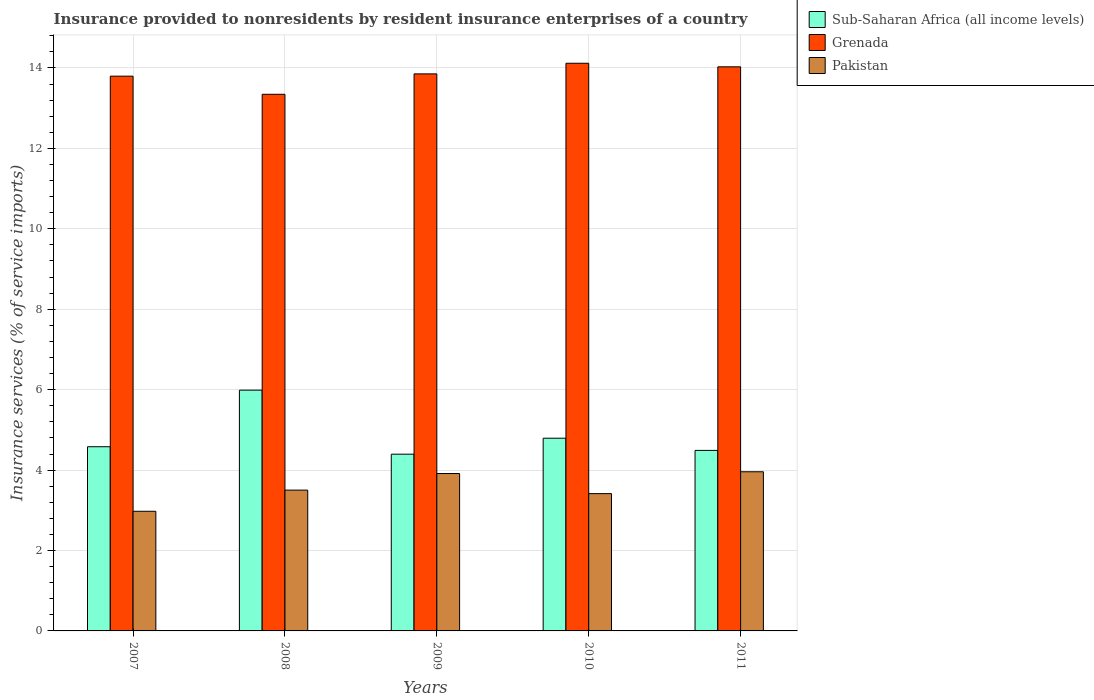Are the number of bars per tick equal to the number of legend labels?
Make the answer very short. Yes. How many bars are there on the 1st tick from the left?
Make the answer very short. 3. What is the insurance provided to nonresidents in Pakistan in 2011?
Provide a succinct answer. 3.96. Across all years, what is the maximum insurance provided to nonresidents in Sub-Saharan Africa (all income levels)?
Keep it short and to the point. 5.99. Across all years, what is the minimum insurance provided to nonresidents in Sub-Saharan Africa (all income levels)?
Keep it short and to the point. 4.4. In which year was the insurance provided to nonresidents in Pakistan maximum?
Keep it short and to the point. 2011. In which year was the insurance provided to nonresidents in Sub-Saharan Africa (all income levels) minimum?
Make the answer very short. 2009. What is the total insurance provided to nonresidents in Grenada in the graph?
Provide a succinct answer. 69.14. What is the difference between the insurance provided to nonresidents in Pakistan in 2007 and that in 2011?
Make the answer very short. -0.98. What is the difference between the insurance provided to nonresidents in Grenada in 2011 and the insurance provided to nonresidents in Sub-Saharan Africa (all income levels) in 2008?
Ensure brevity in your answer.  8.04. What is the average insurance provided to nonresidents in Pakistan per year?
Provide a succinct answer. 3.55. In the year 2008, what is the difference between the insurance provided to nonresidents in Pakistan and insurance provided to nonresidents in Grenada?
Make the answer very short. -9.84. What is the ratio of the insurance provided to nonresidents in Grenada in 2007 to that in 2008?
Ensure brevity in your answer.  1.03. What is the difference between the highest and the second highest insurance provided to nonresidents in Sub-Saharan Africa (all income levels)?
Keep it short and to the point. 1.2. What is the difference between the highest and the lowest insurance provided to nonresidents in Pakistan?
Give a very brief answer. 0.98. In how many years, is the insurance provided to nonresidents in Grenada greater than the average insurance provided to nonresidents in Grenada taken over all years?
Your answer should be compact. 3. Is the sum of the insurance provided to nonresidents in Grenada in 2007 and 2011 greater than the maximum insurance provided to nonresidents in Pakistan across all years?
Keep it short and to the point. Yes. What does the 1st bar from the left in 2007 represents?
Offer a terse response. Sub-Saharan Africa (all income levels). What does the 3rd bar from the right in 2007 represents?
Keep it short and to the point. Sub-Saharan Africa (all income levels). Is it the case that in every year, the sum of the insurance provided to nonresidents in Grenada and insurance provided to nonresidents in Sub-Saharan Africa (all income levels) is greater than the insurance provided to nonresidents in Pakistan?
Offer a terse response. Yes. What is the difference between two consecutive major ticks on the Y-axis?
Ensure brevity in your answer.  2. Does the graph contain any zero values?
Your answer should be compact. No. Does the graph contain grids?
Provide a succinct answer. Yes. Where does the legend appear in the graph?
Your answer should be compact. Top right. How many legend labels are there?
Make the answer very short. 3. How are the legend labels stacked?
Your response must be concise. Vertical. What is the title of the graph?
Give a very brief answer. Insurance provided to nonresidents by resident insurance enterprises of a country. What is the label or title of the X-axis?
Offer a terse response. Years. What is the label or title of the Y-axis?
Provide a succinct answer. Insurance services (% of service imports). What is the Insurance services (% of service imports) of Sub-Saharan Africa (all income levels) in 2007?
Make the answer very short. 4.58. What is the Insurance services (% of service imports) of Grenada in 2007?
Offer a terse response. 13.8. What is the Insurance services (% of service imports) in Pakistan in 2007?
Make the answer very short. 2.98. What is the Insurance services (% of service imports) of Sub-Saharan Africa (all income levels) in 2008?
Ensure brevity in your answer.  5.99. What is the Insurance services (% of service imports) in Grenada in 2008?
Your answer should be very brief. 13.35. What is the Insurance services (% of service imports) in Pakistan in 2008?
Provide a short and direct response. 3.5. What is the Insurance services (% of service imports) of Sub-Saharan Africa (all income levels) in 2009?
Keep it short and to the point. 4.4. What is the Insurance services (% of service imports) of Grenada in 2009?
Provide a succinct answer. 13.85. What is the Insurance services (% of service imports) in Pakistan in 2009?
Keep it short and to the point. 3.91. What is the Insurance services (% of service imports) of Sub-Saharan Africa (all income levels) in 2010?
Offer a terse response. 4.79. What is the Insurance services (% of service imports) of Grenada in 2010?
Ensure brevity in your answer.  14.12. What is the Insurance services (% of service imports) in Pakistan in 2010?
Ensure brevity in your answer.  3.41. What is the Insurance services (% of service imports) in Sub-Saharan Africa (all income levels) in 2011?
Offer a very short reply. 4.49. What is the Insurance services (% of service imports) of Grenada in 2011?
Ensure brevity in your answer.  14.03. What is the Insurance services (% of service imports) of Pakistan in 2011?
Make the answer very short. 3.96. Across all years, what is the maximum Insurance services (% of service imports) of Sub-Saharan Africa (all income levels)?
Give a very brief answer. 5.99. Across all years, what is the maximum Insurance services (% of service imports) in Grenada?
Keep it short and to the point. 14.12. Across all years, what is the maximum Insurance services (% of service imports) of Pakistan?
Offer a terse response. 3.96. Across all years, what is the minimum Insurance services (% of service imports) of Sub-Saharan Africa (all income levels)?
Provide a short and direct response. 4.4. Across all years, what is the minimum Insurance services (% of service imports) in Grenada?
Offer a terse response. 13.35. Across all years, what is the minimum Insurance services (% of service imports) in Pakistan?
Keep it short and to the point. 2.98. What is the total Insurance services (% of service imports) of Sub-Saharan Africa (all income levels) in the graph?
Your answer should be compact. 24.25. What is the total Insurance services (% of service imports) in Grenada in the graph?
Provide a short and direct response. 69.14. What is the total Insurance services (% of service imports) of Pakistan in the graph?
Ensure brevity in your answer.  17.77. What is the difference between the Insurance services (% of service imports) in Sub-Saharan Africa (all income levels) in 2007 and that in 2008?
Offer a very short reply. -1.41. What is the difference between the Insurance services (% of service imports) in Grenada in 2007 and that in 2008?
Offer a terse response. 0.45. What is the difference between the Insurance services (% of service imports) of Pakistan in 2007 and that in 2008?
Offer a terse response. -0.53. What is the difference between the Insurance services (% of service imports) of Sub-Saharan Africa (all income levels) in 2007 and that in 2009?
Ensure brevity in your answer.  0.19. What is the difference between the Insurance services (% of service imports) in Grenada in 2007 and that in 2009?
Keep it short and to the point. -0.06. What is the difference between the Insurance services (% of service imports) in Pakistan in 2007 and that in 2009?
Offer a terse response. -0.94. What is the difference between the Insurance services (% of service imports) of Sub-Saharan Africa (all income levels) in 2007 and that in 2010?
Your answer should be compact. -0.21. What is the difference between the Insurance services (% of service imports) in Grenada in 2007 and that in 2010?
Offer a terse response. -0.32. What is the difference between the Insurance services (% of service imports) in Pakistan in 2007 and that in 2010?
Your response must be concise. -0.44. What is the difference between the Insurance services (% of service imports) in Sub-Saharan Africa (all income levels) in 2007 and that in 2011?
Provide a short and direct response. 0.09. What is the difference between the Insurance services (% of service imports) of Grenada in 2007 and that in 2011?
Offer a terse response. -0.23. What is the difference between the Insurance services (% of service imports) of Pakistan in 2007 and that in 2011?
Ensure brevity in your answer.  -0.98. What is the difference between the Insurance services (% of service imports) of Sub-Saharan Africa (all income levels) in 2008 and that in 2009?
Offer a terse response. 1.59. What is the difference between the Insurance services (% of service imports) of Grenada in 2008 and that in 2009?
Make the answer very short. -0.51. What is the difference between the Insurance services (% of service imports) in Pakistan in 2008 and that in 2009?
Your answer should be very brief. -0.41. What is the difference between the Insurance services (% of service imports) of Sub-Saharan Africa (all income levels) in 2008 and that in 2010?
Your answer should be very brief. 1.2. What is the difference between the Insurance services (% of service imports) of Grenada in 2008 and that in 2010?
Keep it short and to the point. -0.77. What is the difference between the Insurance services (% of service imports) of Pakistan in 2008 and that in 2010?
Ensure brevity in your answer.  0.09. What is the difference between the Insurance services (% of service imports) of Sub-Saharan Africa (all income levels) in 2008 and that in 2011?
Keep it short and to the point. 1.5. What is the difference between the Insurance services (% of service imports) in Grenada in 2008 and that in 2011?
Keep it short and to the point. -0.68. What is the difference between the Insurance services (% of service imports) of Pakistan in 2008 and that in 2011?
Your response must be concise. -0.46. What is the difference between the Insurance services (% of service imports) in Sub-Saharan Africa (all income levels) in 2009 and that in 2010?
Make the answer very short. -0.4. What is the difference between the Insurance services (% of service imports) of Grenada in 2009 and that in 2010?
Make the answer very short. -0.26. What is the difference between the Insurance services (% of service imports) of Pakistan in 2009 and that in 2010?
Your answer should be compact. 0.5. What is the difference between the Insurance services (% of service imports) of Sub-Saharan Africa (all income levels) in 2009 and that in 2011?
Make the answer very short. -0.09. What is the difference between the Insurance services (% of service imports) of Grenada in 2009 and that in 2011?
Keep it short and to the point. -0.18. What is the difference between the Insurance services (% of service imports) in Pakistan in 2009 and that in 2011?
Make the answer very short. -0.04. What is the difference between the Insurance services (% of service imports) in Sub-Saharan Africa (all income levels) in 2010 and that in 2011?
Ensure brevity in your answer.  0.3. What is the difference between the Insurance services (% of service imports) of Grenada in 2010 and that in 2011?
Keep it short and to the point. 0.09. What is the difference between the Insurance services (% of service imports) of Pakistan in 2010 and that in 2011?
Ensure brevity in your answer.  -0.54. What is the difference between the Insurance services (% of service imports) in Sub-Saharan Africa (all income levels) in 2007 and the Insurance services (% of service imports) in Grenada in 2008?
Your answer should be compact. -8.77. What is the difference between the Insurance services (% of service imports) of Sub-Saharan Africa (all income levels) in 2007 and the Insurance services (% of service imports) of Pakistan in 2008?
Your response must be concise. 1.08. What is the difference between the Insurance services (% of service imports) of Grenada in 2007 and the Insurance services (% of service imports) of Pakistan in 2008?
Provide a succinct answer. 10.3. What is the difference between the Insurance services (% of service imports) of Sub-Saharan Africa (all income levels) in 2007 and the Insurance services (% of service imports) of Grenada in 2009?
Offer a very short reply. -9.27. What is the difference between the Insurance services (% of service imports) in Sub-Saharan Africa (all income levels) in 2007 and the Insurance services (% of service imports) in Pakistan in 2009?
Keep it short and to the point. 0.67. What is the difference between the Insurance services (% of service imports) of Grenada in 2007 and the Insurance services (% of service imports) of Pakistan in 2009?
Keep it short and to the point. 9.88. What is the difference between the Insurance services (% of service imports) in Sub-Saharan Africa (all income levels) in 2007 and the Insurance services (% of service imports) in Grenada in 2010?
Offer a terse response. -9.54. What is the difference between the Insurance services (% of service imports) of Sub-Saharan Africa (all income levels) in 2007 and the Insurance services (% of service imports) of Pakistan in 2010?
Your answer should be very brief. 1.17. What is the difference between the Insurance services (% of service imports) in Grenada in 2007 and the Insurance services (% of service imports) in Pakistan in 2010?
Make the answer very short. 10.38. What is the difference between the Insurance services (% of service imports) of Sub-Saharan Africa (all income levels) in 2007 and the Insurance services (% of service imports) of Grenada in 2011?
Give a very brief answer. -9.45. What is the difference between the Insurance services (% of service imports) of Sub-Saharan Africa (all income levels) in 2007 and the Insurance services (% of service imports) of Pakistan in 2011?
Ensure brevity in your answer.  0.62. What is the difference between the Insurance services (% of service imports) of Grenada in 2007 and the Insurance services (% of service imports) of Pakistan in 2011?
Make the answer very short. 9.84. What is the difference between the Insurance services (% of service imports) in Sub-Saharan Africa (all income levels) in 2008 and the Insurance services (% of service imports) in Grenada in 2009?
Make the answer very short. -7.87. What is the difference between the Insurance services (% of service imports) of Sub-Saharan Africa (all income levels) in 2008 and the Insurance services (% of service imports) of Pakistan in 2009?
Ensure brevity in your answer.  2.07. What is the difference between the Insurance services (% of service imports) in Grenada in 2008 and the Insurance services (% of service imports) in Pakistan in 2009?
Keep it short and to the point. 9.43. What is the difference between the Insurance services (% of service imports) of Sub-Saharan Africa (all income levels) in 2008 and the Insurance services (% of service imports) of Grenada in 2010?
Provide a short and direct response. -8.13. What is the difference between the Insurance services (% of service imports) of Sub-Saharan Africa (all income levels) in 2008 and the Insurance services (% of service imports) of Pakistan in 2010?
Ensure brevity in your answer.  2.57. What is the difference between the Insurance services (% of service imports) in Grenada in 2008 and the Insurance services (% of service imports) in Pakistan in 2010?
Ensure brevity in your answer.  9.93. What is the difference between the Insurance services (% of service imports) of Sub-Saharan Africa (all income levels) in 2008 and the Insurance services (% of service imports) of Grenada in 2011?
Your response must be concise. -8.04. What is the difference between the Insurance services (% of service imports) in Sub-Saharan Africa (all income levels) in 2008 and the Insurance services (% of service imports) in Pakistan in 2011?
Provide a short and direct response. 2.03. What is the difference between the Insurance services (% of service imports) in Grenada in 2008 and the Insurance services (% of service imports) in Pakistan in 2011?
Your answer should be compact. 9.39. What is the difference between the Insurance services (% of service imports) in Sub-Saharan Africa (all income levels) in 2009 and the Insurance services (% of service imports) in Grenada in 2010?
Your answer should be compact. -9.72. What is the difference between the Insurance services (% of service imports) of Sub-Saharan Africa (all income levels) in 2009 and the Insurance services (% of service imports) of Pakistan in 2010?
Offer a terse response. 0.98. What is the difference between the Insurance services (% of service imports) of Grenada in 2009 and the Insurance services (% of service imports) of Pakistan in 2010?
Your answer should be very brief. 10.44. What is the difference between the Insurance services (% of service imports) in Sub-Saharan Africa (all income levels) in 2009 and the Insurance services (% of service imports) in Grenada in 2011?
Make the answer very short. -9.63. What is the difference between the Insurance services (% of service imports) in Sub-Saharan Africa (all income levels) in 2009 and the Insurance services (% of service imports) in Pakistan in 2011?
Ensure brevity in your answer.  0.44. What is the difference between the Insurance services (% of service imports) in Grenada in 2009 and the Insurance services (% of service imports) in Pakistan in 2011?
Ensure brevity in your answer.  9.9. What is the difference between the Insurance services (% of service imports) of Sub-Saharan Africa (all income levels) in 2010 and the Insurance services (% of service imports) of Grenada in 2011?
Offer a terse response. -9.24. What is the difference between the Insurance services (% of service imports) in Sub-Saharan Africa (all income levels) in 2010 and the Insurance services (% of service imports) in Pakistan in 2011?
Ensure brevity in your answer.  0.83. What is the difference between the Insurance services (% of service imports) in Grenada in 2010 and the Insurance services (% of service imports) in Pakistan in 2011?
Keep it short and to the point. 10.16. What is the average Insurance services (% of service imports) in Sub-Saharan Africa (all income levels) per year?
Offer a terse response. 4.85. What is the average Insurance services (% of service imports) in Grenada per year?
Keep it short and to the point. 13.83. What is the average Insurance services (% of service imports) in Pakistan per year?
Your response must be concise. 3.55. In the year 2007, what is the difference between the Insurance services (% of service imports) of Sub-Saharan Africa (all income levels) and Insurance services (% of service imports) of Grenada?
Your answer should be compact. -9.22. In the year 2007, what is the difference between the Insurance services (% of service imports) of Sub-Saharan Africa (all income levels) and Insurance services (% of service imports) of Pakistan?
Provide a succinct answer. 1.6. In the year 2007, what is the difference between the Insurance services (% of service imports) in Grenada and Insurance services (% of service imports) in Pakistan?
Offer a terse response. 10.82. In the year 2008, what is the difference between the Insurance services (% of service imports) of Sub-Saharan Africa (all income levels) and Insurance services (% of service imports) of Grenada?
Your answer should be very brief. -7.36. In the year 2008, what is the difference between the Insurance services (% of service imports) of Sub-Saharan Africa (all income levels) and Insurance services (% of service imports) of Pakistan?
Give a very brief answer. 2.49. In the year 2008, what is the difference between the Insurance services (% of service imports) of Grenada and Insurance services (% of service imports) of Pakistan?
Provide a short and direct response. 9.84. In the year 2009, what is the difference between the Insurance services (% of service imports) in Sub-Saharan Africa (all income levels) and Insurance services (% of service imports) in Grenada?
Ensure brevity in your answer.  -9.46. In the year 2009, what is the difference between the Insurance services (% of service imports) in Sub-Saharan Africa (all income levels) and Insurance services (% of service imports) in Pakistan?
Your response must be concise. 0.48. In the year 2009, what is the difference between the Insurance services (% of service imports) of Grenada and Insurance services (% of service imports) of Pakistan?
Offer a terse response. 9.94. In the year 2010, what is the difference between the Insurance services (% of service imports) of Sub-Saharan Africa (all income levels) and Insurance services (% of service imports) of Grenada?
Offer a very short reply. -9.32. In the year 2010, what is the difference between the Insurance services (% of service imports) of Sub-Saharan Africa (all income levels) and Insurance services (% of service imports) of Pakistan?
Your answer should be compact. 1.38. In the year 2010, what is the difference between the Insurance services (% of service imports) of Grenada and Insurance services (% of service imports) of Pakistan?
Make the answer very short. 10.7. In the year 2011, what is the difference between the Insurance services (% of service imports) of Sub-Saharan Africa (all income levels) and Insurance services (% of service imports) of Grenada?
Keep it short and to the point. -9.54. In the year 2011, what is the difference between the Insurance services (% of service imports) in Sub-Saharan Africa (all income levels) and Insurance services (% of service imports) in Pakistan?
Keep it short and to the point. 0.53. In the year 2011, what is the difference between the Insurance services (% of service imports) of Grenada and Insurance services (% of service imports) of Pakistan?
Make the answer very short. 10.07. What is the ratio of the Insurance services (% of service imports) of Sub-Saharan Africa (all income levels) in 2007 to that in 2008?
Offer a very short reply. 0.77. What is the ratio of the Insurance services (% of service imports) in Grenada in 2007 to that in 2008?
Provide a succinct answer. 1.03. What is the ratio of the Insurance services (% of service imports) in Pakistan in 2007 to that in 2008?
Make the answer very short. 0.85. What is the ratio of the Insurance services (% of service imports) of Sub-Saharan Africa (all income levels) in 2007 to that in 2009?
Your answer should be compact. 1.04. What is the ratio of the Insurance services (% of service imports) of Pakistan in 2007 to that in 2009?
Provide a short and direct response. 0.76. What is the ratio of the Insurance services (% of service imports) in Sub-Saharan Africa (all income levels) in 2007 to that in 2010?
Offer a terse response. 0.96. What is the ratio of the Insurance services (% of service imports) of Grenada in 2007 to that in 2010?
Provide a short and direct response. 0.98. What is the ratio of the Insurance services (% of service imports) in Pakistan in 2007 to that in 2010?
Your answer should be compact. 0.87. What is the ratio of the Insurance services (% of service imports) of Sub-Saharan Africa (all income levels) in 2007 to that in 2011?
Ensure brevity in your answer.  1.02. What is the ratio of the Insurance services (% of service imports) in Grenada in 2007 to that in 2011?
Give a very brief answer. 0.98. What is the ratio of the Insurance services (% of service imports) in Pakistan in 2007 to that in 2011?
Provide a succinct answer. 0.75. What is the ratio of the Insurance services (% of service imports) of Sub-Saharan Africa (all income levels) in 2008 to that in 2009?
Your answer should be compact. 1.36. What is the ratio of the Insurance services (% of service imports) in Grenada in 2008 to that in 2009?
Your response must be concise. 0.96. What is the ratio of the Insurance services (% of service imports) in Pakistan in 2008 to that in 2009?
Offer a very short reply. 0.89. What is the ratio of the Insurance services (% of service imports) of Sub-Saharan Africa (all income levels) in 2008 to that in 2010?
Ensure brevity in your answer.  1.25. What is the ratio of the Insurance services (% of service imports) in Grenada in 2008 to that in 2010?
Provide a succinct answer. 0.95. What is the ratio of the Insurance services (% of service imports) of Pakistan in 2008 to that in 2010?
Provide a short and direct response. 1.03. What is the ratio of the Insurance services (% of service imports) in Sub-Saharan Africa (all income levels) in 2008 to that in 2011?
Ensure brevity in your answer.  1.33. What is the ratio of the Insurance services (% of service imports) in Grenada in 2008 to that in 2011?
Keep it short and to the point. 0.95. What is the ratio of the Insurance services (% of service imports) in Pakistan in 2008 to that in 2011?
Ensure brevity in your answer.  0.88. What is the ratio of the Insurance services (% of service imports) of Sub-Saharan Africa (all income levels) in 2009 to that in 2010?
Your answer should be very brief. 0.92. What is the ratio of the Insurance services (% of service imports) of Grenada in 2009 to that in 2010?
Provide a succinct answer. 0.98. What is the ratio of the Insurance services (% of service imports) in Pakistan in 2009 to that in 2010?
Offer a terse response. 1.15. What is the ratio of the Insurance services (% of service imports) of Sub-Saharan Africa (all income levels) in 2009 to that in 2011?
Your answer should be compact. 0.98. What is the ratio of the Insurance services (% of service imports) in Grenada in 2009 to that in 2011?
Offer a terse response. 0.99. What is the ratio of the Insurance services (% of service imports) of Pakistan in 2009 to that in 2011?
Your answer should be very brief. 0.99. What is the ratio of the Insurance services (% of service imports) in Sub-Saharan Africa (all income levels) in 2010 to that in 2011?
Provide a succinct answer. 1.07. What is the ratio of the Insurance services (% of service imports) in Grenada in 2010 to that in 2011?
Offer a terse response. 1.01. What is the ratio of the Insurance services (% of service imports) in Pakistan in 2010 to that in 2011?
Make the answer very short. 0.86. What is the difference between the highest and the second highest Insurance services (% of service imports) of Sub-Saharan Africa (all income levels)?
Your answer should be very brief. 1.2. What is the difference between the highest and the second highest Insurance services (% of service imports) of Grenada?
Ensure brevity in your answer.  0.09. What is the difference between the highest and the second highest Insurance services (% of service imports) in Pakistan?
Your response must be concise. 0.04. What is the difference between the highest and the lowest Insurance services (% of service imports) in Sub-Saharan Africa (all income levels)?
Offer a very short reply. 1.59. What is the difference between the highest and the lowest Insurance services (% of service imports) in Grenada?
Provide a short and direct response. 0.77. What is the difference between the highest and the lowest Insurance services (% of service imports) of Pakistan?
Provide a short and direct response. 0.98. 